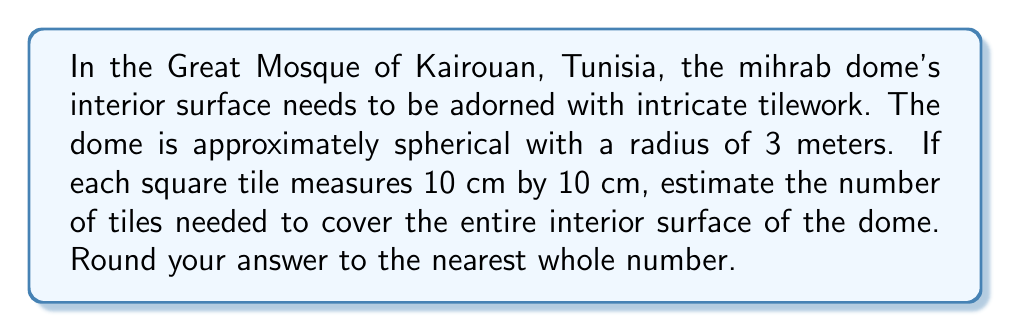Show me your answer to this math problem. To solve this problem, we need to follow these steps:

1. Calculate the surface area of the spherical dome:
   The surface area of a sphere is given by the formula $A = 4\pi r^2$, where $r$ is the radius.

   $$A = 4\pi (3\text{ m})^2 = 36\pi \text{ m}^2$$

2. Convert the surface area to square centimeters:
   $$36\pi \text{ m}^2 = 36\pi \times 10000 \text{ cm}^2 = 360000\pi \text{ cm}^2$$

3. Calculate the area of a single tile:
   Each tile is 10 cm by 10 cm, so its area is:
   $$10 \text{ cm} \times 10 \text{ cm} = 100 \text{ cm}^2$$

4. Divide the total surface area by the area of a single tile:
   $$\text{Number of tiles} = \frac{360000\pi \text{ cm}^2}{100 \text{ cm}^2} = 3600\pi$$

5. Calculate the result and round to the nearest whole number:
   $$3600\pi \approx 11309.7331$$

   Rounding to the nearest whole number gives us 11310 tiles.

Note: This calculation assumes perfect coverage without accounting for cuts or waste. In practice, additional tiles may be needed to account for irregularities and artistic design considerations.
Answer: 11310 tiles 